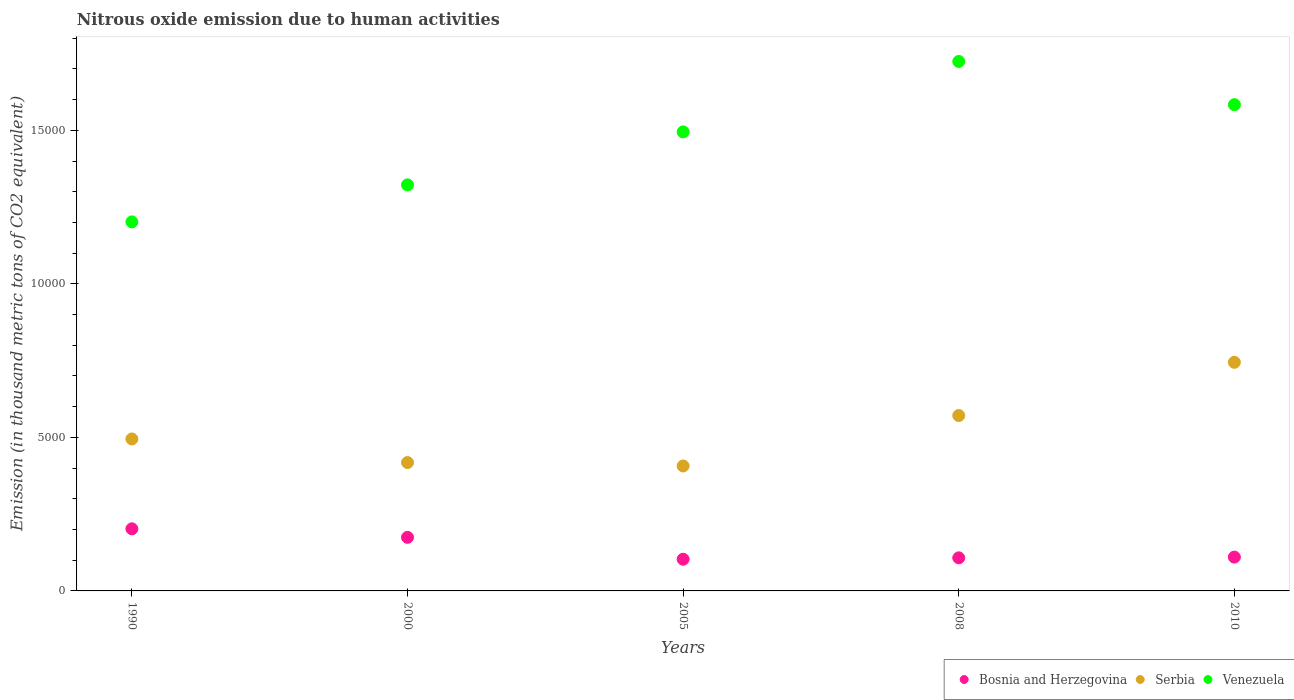How many different coloured dotlines are there?
Make the answer very short. 3. What is the amount of nitrous oxide emitted in Venezuela in 2010?
Keep it short and to the point. 1.58e+04. Across all years, what is the maximum amount of nitrous oxide emitted in Serbia?
Provide a succinct answer. 7444.9. Across all years, what is the minimum amount of nitrous oxide emitted in Bosnia and Herzegovina?
Your answer should be compact. 1032.3. In which year was the amount of nitrous oxide emitted in Venezuela maximum?
Give a very brief answer. 2008. What is the total amount of nitrous oxide emitted in Serbia in the graph?
Ensure brevity in your answer.  2.64e+04. What is the difference between the amount of nitrous oxide emitted in Venezuela in 2000 and that in 2008?
Provide a succinct answer. -4018.8. What is the difference between the amount of nitrous oxide emitted in Venezuela in 1990 and the amount of nitrous oxide emitted in Bosnia and Herzegovina in 2005?
Your response must be concise. 1.10e+04. What is the average amount of nitrous oxide emitted in Serbia per year?
Provide a succinct answer. 5271.12. In the year 1990, what is the difference between the amount of nitrous oxide emitted in Bosnia and Herzegovina and amount of nitrous oxide emitted in Venezuela?
Provide a short and direct response. -9995.4. In how many years, is the amount of nitrous oxide emitted in Venezuela greater than 5000 thousand metric tons?
Your answer should be compact. 5. What is the ratio of the amount of nitrous oxide emitted in Bosnia and Herzegovina in 2000 to that in 2005?
Offer a very short reply. 1.69. What is the difference between the highest and the second highest amount of nitrous oxide emitted in Bosnia and Herzegovina?
Give a very brief answer. 277.7. What is the difference between the highest and the lowest amount of nitrous oxide emitted in Bosnia and Herzegovina?
Give a very brief answer. 990.3. In how many years, is the amount of nitrous oxide emitted in Bosnia and Herzegovina greater than the average amount of nitrous oxide emitted in Bosnia and Herzegovina taken over all years?
Your answer should be very brief. 2. Is the sum of the amount of nitrous oxide emitted in Serbia in 1990 and 2010 greater than the maximum amount of nitrous oxide emitted in Bosnia and Herzegovina across all years?
Make the answer very short. Yes. Does the amount of nitrous oxide emitted in Bosnia and Herzegovina monotonically increase over the years?
Offer a very short reply. No. Is the amount of nitrous oxide emitted in Serbia strictly greater than the amount of nitrous oxide emitted in Bosnia and Herzegovina over the years?
Your answer should be very brief. Yes. Is the amount of nitrous oxide emitted in Bosnia and Herzegovina strictly less than the amount of nitrous oxide emitted in Serbia over the years?
Your response must be concise. Yes. How many years are there in the graph?
Your answer should be very brief. 5. Are the values on the major ticks of Y-axis written in scientific E-notation?
Keep it short and to the point. No. Does the graph contain any zero values?
Ensure brevity in your answer.  No. Where does the legend appear in the graph?
Make the answer very short. Bottom right. How many legend labels are there?
Provide a short and direct response. 3. How are the legend labels stacked?
Your response must be concise. Horizontal. What is the title of the graph?
Ensure brevity in your answer.  Nitrous oxide emission due to human activities. Does "Canada" appear as one of the legend labels in the graph?
Keep it short and to the point. No. What is the label or title of the Y-axis?
Provide a short and direct response. Emission (in thousand metric tons of CO2 equivalent). What is the Emission (in thousand metric tons of CO2 equivalent) of Bosnia and Herzegovina in 1990?
Ensure brevity in your answer.  2022.6. What is the Emission (in thousand metric tons of CO2 equivalent) in Serbia in 1990?
Make the answer very short. 4948.7. What is the Emission (in thousand metric tons of CO2 equivalent) of Venezuela in 1990?
Make the answer very short. 1.20e+04. What is the Emission (in thousand metric tons of CO2 equivalent) in Bosnia and Herzegovina in 2000?
Keep it short and to the point. 1744.9. What is the Emission (in thousand metric tons of CO2 equivalent) in Serbia in 2000?
Your answer should be compact. 4181. What is the Emission (in thousand metric tons of CO2 equivalent) of Venezuela in 2000?
Keep it short and to the point. 1.32e+04. What is the Emission (in thousand metric tons of CO2 equivalent) of Bosnia and Herzegovina in 2005?
Provide a succinct answer. 1032.3. What is the Emission (in thousand metric tons of CO2 equivalent) in Serbia in 2005?
Provide a short and direct response. 4069.2. What is the Emission (in thousand metric tons of CO2 equivalent) of Venezuela in 2005?
Offer a very short reply. 1.49e+04. What is the Emission (in thousand metric tons of CO2 equivalent) of Bosnia and Herzegovina in 2008?
Offer a very short reply. 1077.6. What is the Emission (in thousand metric tons of CO2 equivalent) in Serbia in 2008?
Provide a succinct answer. 5711.8. What is the Emission (in thousand metric tons of CO2 equivalent) of Venezuela in 2008?
Keep it short and to the point. 1.72e+04. What is the Emission (in thousand metric tons of CO2 equivalent) of Bosnia and Herzegovina in 2010?
Provide a short and direct response. 1101.5. What is the Emission (in thousand metric tons of CO2 equivalent) in Serbia in 2010?
Make the answer very short. 7444.9. What is the Emission (in thousand metric tons of CO2 equivalent) in Venezuela in 2010?
Provide a succinct answer. 1.58e+04. Across all years, what is the maximum Emission (in thousand metric tons of CO2 equivalent) of Bosnia and Herzegovina?
Keep it short and to the point. 2022.6. Across all years, what is the maximum Emission (in thousand metric tons of CO2 equivalent) of Serbia?
Offer a terse response. 7444.9. Across all years, what is the maximum Emission (in thousand metric tons of CO2 equivalent) in Venezuela?
Provide a short and direct response. 1.72e+04. Across all years, what is the minimum Emission (in thousand metric tons of CO2 equivalent) of Bosnia and Herzegovina?
Your answer should be compact. 1032.3. Across all years, what is the minimum Emission (in thousand metric tons of CO2 equivalent) of Serbia?
Provide a short and direct response. 4069.2. Across all years, what is the minimum Emission (in thousand metric tons of CO2 equivalent) in Venezuela?
Make the answer very short. 1.20e+04. What is the total Emission (in thousand metric tons of CO2 equivalent) in Bosnia and Herzegovina in the graph?
Give a very brief answer. 6978.9. What is the total Emission (in thousand metric tons of CO2 equivalent) of Serbia in the graph?
Your answer should be compact. 2.64e+04. What is the total Emission (in thousand metric tons of CO2 equivalent) of Venezuela in the graph?
Keep it short and to the point. 7.33e+04. What is the difference between the Emission (in thousand metric tons of CO2 equivalent) in Bosnia and Herzegovina in 1990 and that in 2000?
Make the answer very short. 277.7. What is the difference between the Emission (in thousand metric tons of CO2 equivalent) in Serbia in 1990 and that in 2000?
Make the answer very short. 767.7. What is the difference between the Emission (in thousand metric tons of CO2 equivalent) of Venezuela in 1990 and that in 2000?
Your answer should be very brief. -1205.8. What is the difference between the Emission (in thousand metric tons of CO2 equivalent) in Bosnia and Herzegovina in 1990 and that in 2005?
Give a very brief answer. 990.3. What is the difference between the Emission (in thousand metric tons of CO2 equivalent) in Serbia in 1990 and that in 2005?
Your answer should be compact. 879.5. What is the difference between the Emission (in thousand metric tons of CO2 equivalent) in Venezuela in 1990 and that in 2005?
Your response must be concise. -2931.2. What is the difference between the Emission (in thousand metric tons of CO2 equivalent) of Bosnia and Herzegovina in 1990 and that in 2008?
Provide a succinct answer. 945. What is the difference between the Emission (in thousand metric tons of CO2 equivalent) of Serbia in 1990 and that in 2008?
Your answer should be compact. -763.1. What is the difference between the Emission (in thousand metric tons of CO2 equivalent) of Venezuela in 1990 and that in 2008?
Offer a terse response. -5224.6. What is the difference between the Emission (in thousand metric tons of CO2 equivalent) of Bosnia and Herzegovina in 1990 and that in 2010?
Give a very brief answer. 921.1. What is the difference between the Emission (in thousand metric tons of CO2 equivalent) in Serbia in 1990 and that in 2010?
Offer a terse response. -2496.2. What is the difference between the Emission (in thousand metric tons of CO2 equivalent) in Venezuela in 1990 and that in 2010?
Provide a short and direct response. -3818.1. What is the difference between the Emission (in thousand metric tons of CO2 equivalent) in Bosnia and Herzegovina in 2000 and that in 2005?
Keep it short and to the point. 712.6. What is the difference between the Emission (in thousand metric tons of CO2 equivalent) of Serbia in 2000 and that in 2005?
Provide a short and direct response. 111.8. What is the difference between the Emission (in thousand metric tons of CO2 equivalent) in Venezuela in 2000 and that in 2005?
Provide a succinct answer. -1725.4. What is the difference between the Emission (in thousand metric tons of CO2 equivalent) of Bosnia and Herzegovina in 2000 and that in 2008?
Give a very brief answer. 667.3. What is the difference between the Emission (in thousand metric tons of CO2 equivalent) in Serbia in 2000 and that in 2008?
Your response must be concise. -1530.8. What is the difference between the Emission (in thousand metric tons of CO2 equivalent) in Venezuela in 2000 and that in 2008?
Provide a succinct answer. -4018.8. What is the difference between the Emission (in thousand metric tons of CO2 equivalent) of Bosnia and Herzegovina in 2000 and that in 2010?
Make the answer very short. 643.4. What is the difference between the Emission (in thousand metric tons of CO2 equivalent) in Serbia in 2000 and that in 2010?
Ensure brevity in your answer.  -3263.9. What is the difference between the Emission (in thousand metric tons of CO2 equivalent) of Venezuela in 2000 and that in 2010?
Your answer should be compact. -2612.3. What is the difference between the Emission (in thousand metric tons of CO2 equivalent) in Bosnia and Herzegovina in 2005 and that in 2008?
Offer a terse response. -45.3. What is the difference between the Emission (in thousand metric tons of CO2 equivalent) in Serbia in 2005 and that in 2008?
Offer a very short reply. -1642.6. What is the difference between the Emission (in thousand metric tons of CO2 equivalent) in Venezuela in 2005 and that in 2008?
Provide a short and direct response. -2293.4. What is the difference between the Emission (in thousand metric tons of CO2 equivalent) in Bosnia and Herzegovina in 2005 and that in 2010?
Your response must be concise. -69.2. What is the difference between the Emission (in thousand metric tons of CO2 equivalent) of Serbia in 2005 and that in 2010?
Offer a very short reply. -3375.7. What is the difference between the Emission (in thousand metric tons of CO2 equivalent) in Venezuela in 2005 and that in 2010?
Your answer should be very brief. -886.9. What is the difference between the Emission (in thousand metric tons of CO2 equivalent) in Bosnia and Herzegovina in 2008 and that in 2010?
Provide a succinct answer. -23.9. What is the difference between the Emission (in thousand metric tons of CO2 equivalent) in Serbia in 2008 and that in 2010?
Make the answer very short. -1733.1. What is the difference between the Emission (in thousand metric tons of CO2 equivalent) of Venezuela in 2008 and that in 2010?
Ensure brevity in your answer.  1406.5. What is the difference between the Emission (in thousand metric tons of CO2 equivalent) of Bosnia and Herzegovina in 1990 and the Emission (in thousand metric tons of CO2 equivalent) of Serbia in 2000?
Give a very brief answer. -2158.4. What is the difference between the Emission (in thousand metric tons of CO2 equivalent) in Bosnia and Herzegovina in 1990 and the Emission (in thousand metric tons of CO2 equivalent) in Venezuela in 2000?
Your response must be concise. -1.12e+04. What is the difference between the Emission (in thousand metric tons of CO2 equivalent) in Serbia in 1990 and the Emission (in thousand metric tons of CO2 equivalent) in Venezuela in 2000?
Make the answer very short. -8275.1. What is the difference between the Emission (in thousand metric tons of CO2 equivalent) in Bosnia and Herzegovina in 1990 and the Emission (in thousand metric tons of CO2 equivalent) in Serbia in 2005?
Offer a terse response. -2046.6. What is the difference between the Emission (in thousand metric tons of CO2 equivalent) in Bosnia and Herzegovina in 1990 and the Emission (in thousand metric tons of CO2 equivalent) in Venezuela in 2005?
Provide a succinct answer. -1.29e+04. What is the difference between the Emission (in thousand metric tons of CO2 equivalent) in Serbia in 1990 and the Emission (in thousand metric tons of CO2 equivalent) in Venezuela in 2005?
Your response must be concise. -1.00e+04. What is the difference between the Emission (in thousand metric tons of CO2 equivalent) of Bosnia and Herzegovina in 1990 and the Emission (in thousand metric tons of CO2 equivalent) of Serbia in 2008?
Make the answer very short. -3689.2. What is the difference between the Emission (in thousand metric tons of CO2 equivalent) in Bosnia and Herzegovina in 1990 and the Emission (in thousand metric tons of CO2 equivalent) in Venezuela in 2008?
Offer a terse response. -1.52e+04. What is the difference between the Emission (in thousand metric tons of CO2 equivalent) of Serbia in 1990 and the Emission (in thousand metric tons of CO2 equivalent) of Venezuela in 2008?
Provide a succinct answer. -1.23e+04. What is the difference between the Emission (in thousand metric tons of CO2 equivalent) in Bosnia and Herzegovina in 1990 and the Emission (in thousand metric tons of CO2 equivalent) in Serbia in 2010?
Your answer should be compact. -5422.3. What is the difference between the Emission (in thousand metric tons of CO2 equivalent) in Bosnia and Herzegovina in 1990 and the Emission (in thousand metric tons of CO2 equivalent) in Venezuela in 2010?
Provide a succinct answer. -1.38e+04. What is the difference between the Emission (in thousand metric tons of CO2 equivalent) in Serbia in 1990 and the Emission (in thousand metric tons of CO2 equivalent) in Venezuela in 2010?
Your answer should be very brief. -1.09e+04. What is the difference between the Emission (in thousand metric tons of CO2 equivalent) of Bosnia and Herzegovina in 2000 and the Emission (in thousand metric tons of CO2 equivalent) of Serbia in 2005?
Provide a succinct answer. -2324.3. What is the difference between the Emission (in thousand metric tons of CO2 equivalent) of Bosnia and Herzegovina in 2000 and the Emission (in thousand metric tons of CO2 equivalent) of Venezuela in 2005?
Your answer should be very brief. -1.32e+04. What is the difference between the Emission (in thousand metric tons of CO2 equivalent) in Serbia in 2000 and the Emission (in thousand metric tons of CO2 equivalent) in Venezuela in 2005?
Your answer should be compact. -1.08e+04. What is the difference between the Emission (in thousand metric tons of CO2 equivalent) in Bosnia and Herzegovina in 2000 and the Emission (in thousand metric tons of CO2 equivalent) in Serbia in 2008?
Give a very brief answer. -3966.9. What is the difference between the Emission (in thousand metric tons of CO2 equivalent) in Bosnia and Herzegovina in 2000 and the Emission (in thousand metric tons of CO2 equivalent) in Venezuela in 2008?
Your response must be concise. -1.55e+04. What is the difference between the Emission (in thousand metric tons of CO2 equivalent) of Serbia in 2000 and the Emission (in thousand metric tons of CO2 equivalent) of Venezuela in 2008?
Ensure brevity in your answer.  -1.31e+04. What is the difference between the Emission (in thousand metric tons of CO2 equivalent) in Bosnia and Herzegovina in 2000 and the Emission (in thousand metric tons of CO2 equivalent) in Serbia in 2010?
Your response must be concise. -5700. What is the difference between the Emission (in thousand metric tons of CO2 equivalent) of Bosnia and Herzegovina in 2000 and the Emission (in thousand metric tons of CO2 equivalent) of Venezuela in 2010?
Your response must be concise. -1.41e+04. What is the difference between the Emission (in thousand metric tons of CO2 equivalent) of Serbia in 2000 and the Emission (in thousand metric tons of CO2 equivalent) of Venezuela in 2010?
Keep it short and to the point. -1.17e+04. What is the difference between the Emission (in thousand metric tons of CO2 equivalent) in Bosnia and Herzegovina in 2005 and the Emission (in thousand metric tons of CO2 equivalent) in Serbia in 2008?
Provide a succinct answer. -4679.5. What is the difference between the Emission (in thousand metric tons of CO2 equivalent) in Bosnia and Herzegovina in 2005 and the Emission (in thousand metric tons of CO2 equivalent) in Venezuela in 2008?
Your answer should be very brief. -1.62e+04. What is the difference between the Emission (in thousand metric tons of CO2 equivalent) of Serbia in 2005 and the Emission (in thousand metric tons of CO2 equivalent) of Venezuela in 2008?
Your answer should be very brief. -1.32e+04. What is the difference between the Emission (in thousand metric tons of CO2 equivalent) in Bosnia and Herzegovina in 2005 and the Emission (in thousand metric tons of CO2 equivalent) in Serbia in 2010?
Your answer should be compact. -6412.6. What is the difference between the Emission (in thousand metric tons of CO2 equivalent) in Bosnia and Herzegovina in 2005 and the Emission (in thousand metric tons of CO2 equivalent) in Venezuela in 2010?
Your response must be concise. -1.48e+04. What is the difference between the Emission (in thousand metric tons of CO2 equivalent) of Serbia in 2005 and the Emission (in thousand metric tons of CO2 equivalent) of Venezuela in 2010?
Offer a very short reply. -1.18e+04. What is the difference between the Emission (in thousand metric tons of CO2 equivalent) in Bosnia and Herzegovina in 2008 and the Emission (in thousand metric tons of CO2 equivalent) in Serbia in 2010?
Offer a very short reply. -6367.3. What is the difference between the Emission (in thousand metric tons of CO2 equivalent) of Bosnia and Herzegovina in 2008 and the Emission (in thousand metric tons of CO2 equivalent) of Venezuela in 2010?
Your answer should be compact. -1.48e+04. What is the difference between the Emission (in thousand metric tons of CO2 equivalent) in Serbia in 2008 and the Emission (in thousand metric tons of CO2 equivalent) in Venezuela in 2010?
Provide a succinct answer. -1.01e+04. What is the average Emission (in thousand metric tons of CO2 equivalent) in Bosnia and Herzegovina per year?
Make the answer very short. 1395.78. What is the average Emission (in thousand metric tons of CO2 equivalent) of Serbia per year?
Your response must be concise. 5271.12. What is the average Emission (in thousand metric tons of CO2 equivalent) in Venezuela per year?
Your answer should be very brief. 1.47e+04. In the year 1990, what is the difference between the Emission (in thousand metric tons of CO2 equivalent) in Bosnia and Herzegovina and Emission (in thousand metric tons of CO2 equivalent) in Serbia?
Make the answer very short. -2926.1. In the year 1990, what is the difference between the Emission (in thousand metric tons of CO2 equivalent) in Bosnia and Herzegovina and Emission (in thousand metric tons of CO2 equivalent) in Venezuela?
Your answer should be compact. -9995.4. In the year 1990, what is the difference between the Emission (in thousand metric tons of CO2 equivalent) of Serbia and Emission (in thousand metric tons of CO2 equivalent) of Venezuela?
Give a very brief answer. -7069.3. In the year 2000, what is the difference between the Emission (in thousand metric tons of CO2 equivalent) of Bosnia and Herzegovina and Emission (in thousand metric tons of CO2 equivalent) of Serbia?
Your answer should be very brief. -2436.1. In the year 2000, what is the difference between the Emission (in thousand metric tons of CO2 equivalent) in Bosnia and Herzegovina and Emission (in thousand metric tons of CO2 equivalent) in Venezuela?
Ensure brevity in your answer.  -1.15e+04. In the year 2000, what is the difference between the Emission (in thousand metric tons of CO2 equivalent) of Serbia and Emission (in thousand metric tons of CO2 equivalent) of Venezuela?
Provide a succinct answer. -9042.8. In the year 2005, what is the difference between the Emission (in thousand metric tons of CO2 equivalent) in Bosnia and Herzegovina and Emission (in thousand metric tons of CO2 equivalent) in Serbia?
Your answer should be very brief. -3036.9. In the year 2005, what is the difference between the Emission (in thousand metric tons of CO2 equivalent) in Bosnia and Herzegovina and Emission (in thousand metric tons of CO2 equivalent) in Venezuela?
Provide a short and direct response. -1.39e+04. In the year 2005, what is the difference between the Emission (in thousand metric tons of CO2 equivalent) in Serbia and Emission (in thousand metric tons of CO2 equivalent) in Venezuela?
Keep it short and to the point. -1.09e+04. In the year 2008, what is the difference between the Emission (in thousand metric tons of CO2 equivalent) in Bosnia and Herzegovina and Emission (in thousand metric tons of CO2 equivalent) in Serbia?
Ensure brevity in your answer.  -4634.2. In the year 2008, what is the difference between the Emission (in thousand metric tons of CO2 equivalent) in Bosnia and Herzegovina and Emission (in thousand metric tons of CO2 equivalent) in Venezuela?
Give a very brief answer. -1.62e+04. In the year 2008, what is the difference between the Emission (in thousand metric tons of CO2 equivalent) in Serbia and Emission (in thousand metric tons of CO2 equivalent) in Venezuela?
Make the answer very short. -1.15e+04. In the year 2010, what is the difference between the Emission (in thousand metric tons of CO2 equivalent) in Bosnia and Herzegovina and Emission (in thousand metric tons of CO2 equivalent) in Serbia?
Your response must be concise. -6343.4. In the year 2010, what is the difference between the Emission (in thousand metric tons of CO2 equivalent) in Bosnia and Herzegovina and Emission (in thousand metric tons of CO2 equivalent) in Venezuela?
Keep it short and to the point. -1.47e+04. In the year 2010, what is the difference between the Emission (in thousand metric tons of CO2 equivalent) of Serbia and Emission (in thousand metric tons of CO2 equivalent) of Venezuela?
Your answer should be compact. -8391.2. What is the ratio of the Emission (in thousand metric tons of CO2 equivalent) of Bosnia and Herzegovina in 1990 to that in 2000?
Offer a very short reply. 1.16. What is the ratio of the Emission (in thousand metric tons of CO2 equivalent) of Serbia in 1990 to that in 2000?
Provide a short and direct response. 1.18. What is the ratio of the Emission (in thousand metric tons of CO2 equivalent) of Venezuela in 1990 to that in 2000?
Ensure brevity in your answer.  0.91. What is the ratio of the Emission (in thousand metric tons of CO2 equivalent) in Bosnia and Herzegovina in 1990 to that in 2005?
Keep it short and to the point. 1.96. What is the ratio of the Emission (in thousand metric tons of CO2 equivalent) in Serbia in 1990 to that in 2005?
Provide a succinct answer. 1.22. What is the ratio of the Emission (in thousand metric tons of CO2 equivalent) in Venezuela in 1990 to that in 2005?
Offer a terse response. 0.8. What is the ratio of the Emission (in thousand metric tons of CO2 equivalent) of Bosnia and Herzegovina in 1990 to that in 2008?
Your answer should be compact. 1.88. What is the ratio of the Emission (in thousand metric tons of CO2 equivalent) of Serbia in 1990 to that in 2008?
Keep it short and to the point. 0.87. What is the ratio of the Emission (in thousand metric tons of CO2 equivalent) in Venezuela in 1990 to that in 2008?
Offer a very short reply. 0.7. What is the ratio of the Emission (in thousand metric tons of CO2 equivalent) of Bosnia and Herzegovina in 1990 to that in 2010?
Provide a short and direct response. 1.84. What is the ratio of the Emission (in thousand metric tons of CO2 equivalent) in Serbia in 1990 to that in 2010?
Make the answer very short. 0.66. What is the ratio of the Emission (in thousand metric tons of CO2 equivalent) in Venezuela in 1990 to that in 2010?
Provide a succinct answer. 0.76. What is the ratio of the Emission (in thousand metric tons of CO2 equivalent) of Bosnia and Herzegovina in 2000 to that in 2005?
Keep it short and to the point. 1.69. What is the ratio of the Emission (in thousand metric tons of CO2 equivalent) in Serbia in 2000 to that in 2005?
Ensure brevity in your answer.  1.03. What is the ratio of the Emission (in thousand metric tons of CO2 equivalent) in Venezuela in 2000 to that in 2005?
Provide a succinct answer. 0.88. What is the ratio of the Emission (in thousand metric tons of CO2 equivalent) in Bosnia and Herzegovina in 2000 to that in 2008?
Offer a very short reply. 1.62. What is the ratio of the Emission (in thousand metric tons of CO2 equivalent) in Serbia in 2000 to that in 2008?
Provide a short and direct response. 0.73. What is the ratio of the Emission (in thousand metric tons of CO2 equivalent) of Venezuela in 2000 to that in 2008?
Make the answer very short. 0.77. What is the ratio of the Emission (in thousand metric tons of CO2 equivalent) in Bosnia and Herzegovina in 2000 to that in 2010?
Make the answer very short. 1.58. What is the ratio of the Emission (in thousand metric tons of CO2 equivalent) of Serbia in 2000 to that in 2010?
Ensure brevity in your answer.  0.56. What is the ratio of the Emission (in thousand metric tons of CO2 equivalent) of Venezuela in 2000 to that in 2010?
Your answer should be compact. 0.83. What is the ratio of the Emission (in thousand metric tons of CO2 equivalent) of Bosnia and Herzegovina in 2005 to that in 2008?
Provide a succinct answer. 0.96. What is the ratio of the Emission (in thousand metric tons of CO2 equivalent) of Serbia in 2005 to that in 2008?
Make the answer very short. 0.71. What is the ratio of the Emission (in thousand metric tons of CO2 equivalent) in Venezuela in 2005 to that in 2008?
Ensure brevity in your answer.  0.87. What is the ratio of the Emission (in thousand metric tons of CO2 equivalent) in Bosnia and Herzegovina in 2005 to that in 2010?
Ensure brevity in your answer.  0.94. What is the ratio of the Emission (in thousand metric tons of CO2 equivalent) in Serbia in 2005 to that in 2010?
Ensure brevity in your answer.  0.55. What is the ratio of the Emission (in thousand metric tons of CO2 equivalent) in Venezuela in 2005 to that in 2010?
Give a very brief answer. 0.94. What is the ratio of the Emission (in thousand metric tons of CO2 equivalent) of Bosnia and Herzegovina in 2008 to that in 2010?
Your answer should be very brief. 0.98. What is the ratio of the Emission (in thousand metric tons of CO2 equivalent) of Serbia in 2008 to that in 2010?
Offer a terse response. 0.77. What is the ratio of the Emission (in thousand metric tons of CO2 equivalent) of Venezuela in 2008 to that in 2010?
Your answer should be compact. 1.09. What is the difference between the highest and the second highest Emission (in thousand metric tons of CO2 equivalent) of Bosnia and Herzegovina?
Your response must be concise. 277.7. What is the difference between the highest and the second highest Emission (in thousand metric tons of CO2 equivalent) of Serbia?
Keep it short and to the point. 1733.1. What is the difference between the highest and the second highest Emission (in thousand metric tons of CO2 equivalent) of Venezuela?
Make the answer very short. 1406.5. What is the difference between the highest and the lowest Emission (in thousand metric tons of CO2 equivalent) of Bosnia and Herzegovina?
Offer a terse response. 990.3. What is the difference between the highest and the lowest Emission (in thousand metric tons of CO2 equivalent) in Serbia?
Give a very brief answer. 3375.7. What is the difference between the highest and the lowest Emission (in thousand metric tons of CO2 equivalent) of Venezuela?
Provide a short and direct response. 5224.6. 